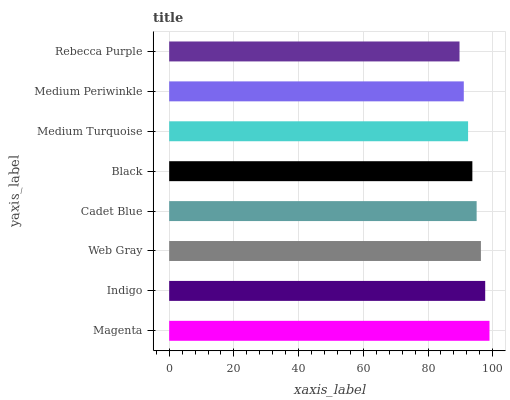Is Rebecca Purple the minimum?
Answer yes or no. Yes. Is Magenta the maximum?
Answer yes or no. Yes. Is Indigo the minimum?
Answer yes or no. No. Is Indigo the maximum?
Answer yes or no. No. Is Magenta greater than Indigo?
Answer yes or no. Yes. Is Indigo less than Magenta?
Answer yes or no. Yes. Is Indigo greater than Magenta?
Answer yes or no. No. Is Magenta less than Indigo?
Answer yes or no. No. Is Cadet Blue the high median?
Answer yes or no. Yes. Is Black the low median?
Answer yes or no. Yes. Is Medium Turquoise the high median?
Answer yes or no. No. Is Magenta the low median?
Answer yes or no. No. 